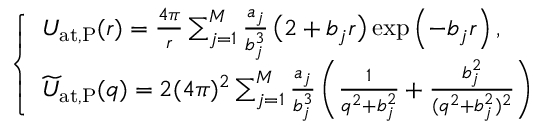Convert formula to latex. <formula><loc_0><loc_0><loc_500><loc_500>\begin{array} { r } { \left \{ \begin{array} { l l } { U _ { a t , P } ( r ) = { \frac { 4 \pi } { r } } \sum _ { j = 1 } ^ { M } { \frac { a _ { j } } { b _ { j } ^ { 3 } } } \, \left ( 2 + b _ { j } r \right ) \exp \left ( - b _ { j } r \right ) , } \\ { \widetilde { U } _ { a t , P } ( q ) = 2 ( 4 \pi ) ^ { 2 } \sum _ { j = 1 } ^ { M } { \frac { a _ { j } } { b _ { j } ^ { 3 } } } \left ( { \frac { 1 } { q ^ { 2 } + b _ { j } ^ { 2 } } } + { \frac { b _ { j } ^ { 2 } } { ( q ^ { 2 } + b _ { j } ^ { 2 } ) ^ { 2 } } } \right ) } \end{array} } \end{array}</formula> 